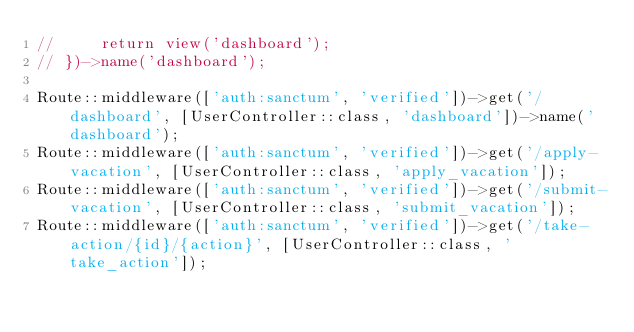Convert code to text. <code><loc_0><loc_0><loc_500><loc_500><_PHP_>//     return view('dashboard');
// })->name('dashboard');

Route::middleware(['auth:sanctum', 'verified'])->get('/dashboard', [UserController::class, 'dashboard'])->name('dashboard');
Route::middleware(['auth:sanctum', 'verified'])->get('/apply-vacation', [UserController::class, 'apply_vacation']);
Route::middleware(['auth:sanctum', 'verified'])->get('/submit-vacation', [UserController::class, 'submit_vacation']);
Route::middleware(['auth:sanctum', 'verified'])->get('/take-action/{id}/{action}', [UserController::class, 'take_action']);
</code> 